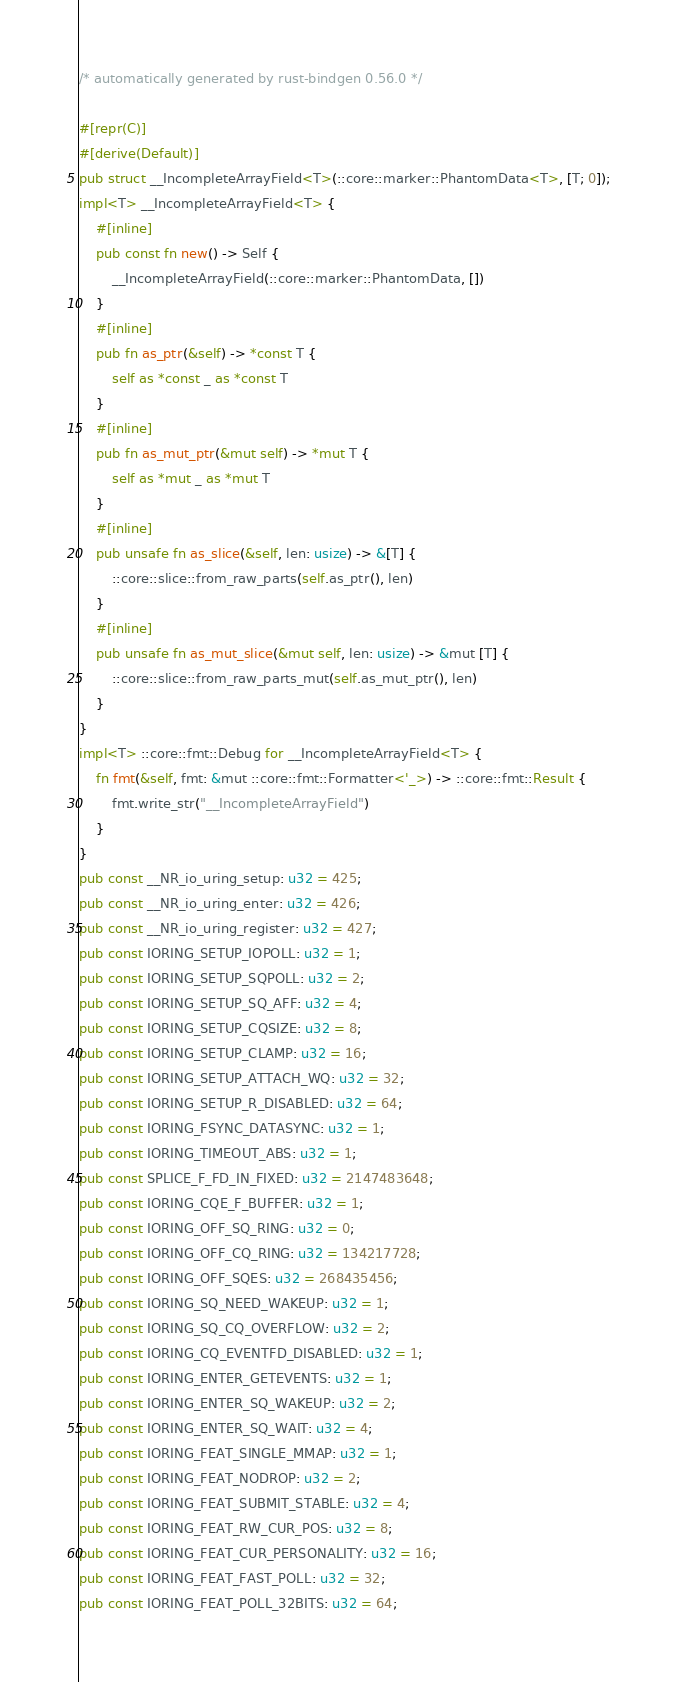Convert code to text. <code><loc_0><loc_0><loc_500><loc_500><_Rust_>/* automatically generated by rust-bindgen 0.56.0 */

#[repr(C)]
#[derive(Default)]
pub struct __IncompleteArrayField<T>(::core::marker::PhantomData<T>, [T; 0]);
impl<T> __IncompleteArrayField<T> {
    #[inline]
    pub const fn new() -> Self {
        __IncompleteArrayField(::core::marker::PhantomData, [])
    }
    #[inline]
    pub fn as_ptr(&self) -> *const T {
        self as *const _ as *const T
    }
    #[inline]
    pub fn as_mut_ptr(&mut self) -> *mut T {
        self as *mut _ as *mut T
    }
    #[inline]
    pub unsafe fn as_slice(&self, len: usize) -> &[T] {
        ::core::slice::from_raw_parts(self.as_ptr(), len)
    }
    #[inline]
    pub unsafe fn as_mut_slice(&mut self, len: usize) -> &mut [T] {
        ::core::slice::from_raw_parts_mut(self.as_mut_ptr(), len)
    }
}
impl<T> ::core::fmt::Debug for __IncompleteArrayField<T> {
    fn fmt(&self, fmt: &mut ::core::fmt::Formatter<'_>) -> ::core::fmt::Result {
        fmt.write_str("__IncompleteArrayField")
    }
}
pub const __NR_io_uring_setup: u32 = 425;
pub const __NR_io_uring_enter: u32 = 426;
pub const __NR_io_uring_register: u32 = 427;
pub const IORING_SETUP_IOPOLL: u32 = 1;
pub const IORING_SETUP_SQPOLL: u32 = 2;
pub const IORING_SETUP_SQ_AFF: u32 = 4;
pub const IORING_SETUP_CQSIZE: u32 = 8;
pub const IORING_SETUP_CLAMP: u32 = 16;
pub const IORING_SETUP_ATTACH_WQ: u32 = 32;
pub const IORING_SETUP_R_DISABLED: u32 = 64;
pub const IORING_FSYNC_DATASYNC: u32 = 1;
pub const IORING_TIMEOUT_ABS: u32 = 1;
pub const SPLICE_F_FD_IN_FIXED: u32 = 2147483648;
pub const IORING_CQE_F_BUFFER: u32 = 1;
pub const IORING_OFF_SQ_RING: u32 = 0;
pub const IORING_OFF_CQ_RING: u32 = 134217728;
pub const IORING_OFF_SQES: u32 = 268435456;
pub const IORING_SQ_NEED_WAKEUP: u32 = 1;
pub const IORING_SQ_CQ_OVERFLOW: u32 = 2;
pub const IORING_CQ_EVENTFD_DISABLED: u32 = 1;
pub const IORING_ENTER_GETEVENTS: u32 = 1;
pub const IORING_ENTER_SQ_WAKEUP: u32 = 2;
pub const IORING_ENTER_SQ_WAIT: u32 = 4;
pub const IORING_FEAT_SINGLE_MMAP: u32 = 1;
pub const IORING_FEAT_NODROP: u32 = 2;
pub const IORING_FEAT_SUBMIT_STABLE: u32 = 4;
pub const IORING_FEAT_RW_CUR_POS: u32 = 8;
pub const IORING_FEAT_CUR_PERSONALITY: u32 = 16;
pub const IORING_FEAT_FAST_POLL: u32 = 32;
pub const IORING_FEAT_POLL_32BITS: u32 = 64;</code> 